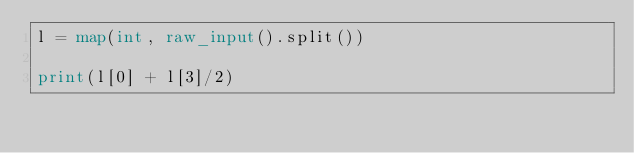Convert code to text. <code><loc_0><loc_0><loc_500><loc_500><_Python_>l = map(int, raw_input().split())

print(l[0] + l[3]/2)</code> 